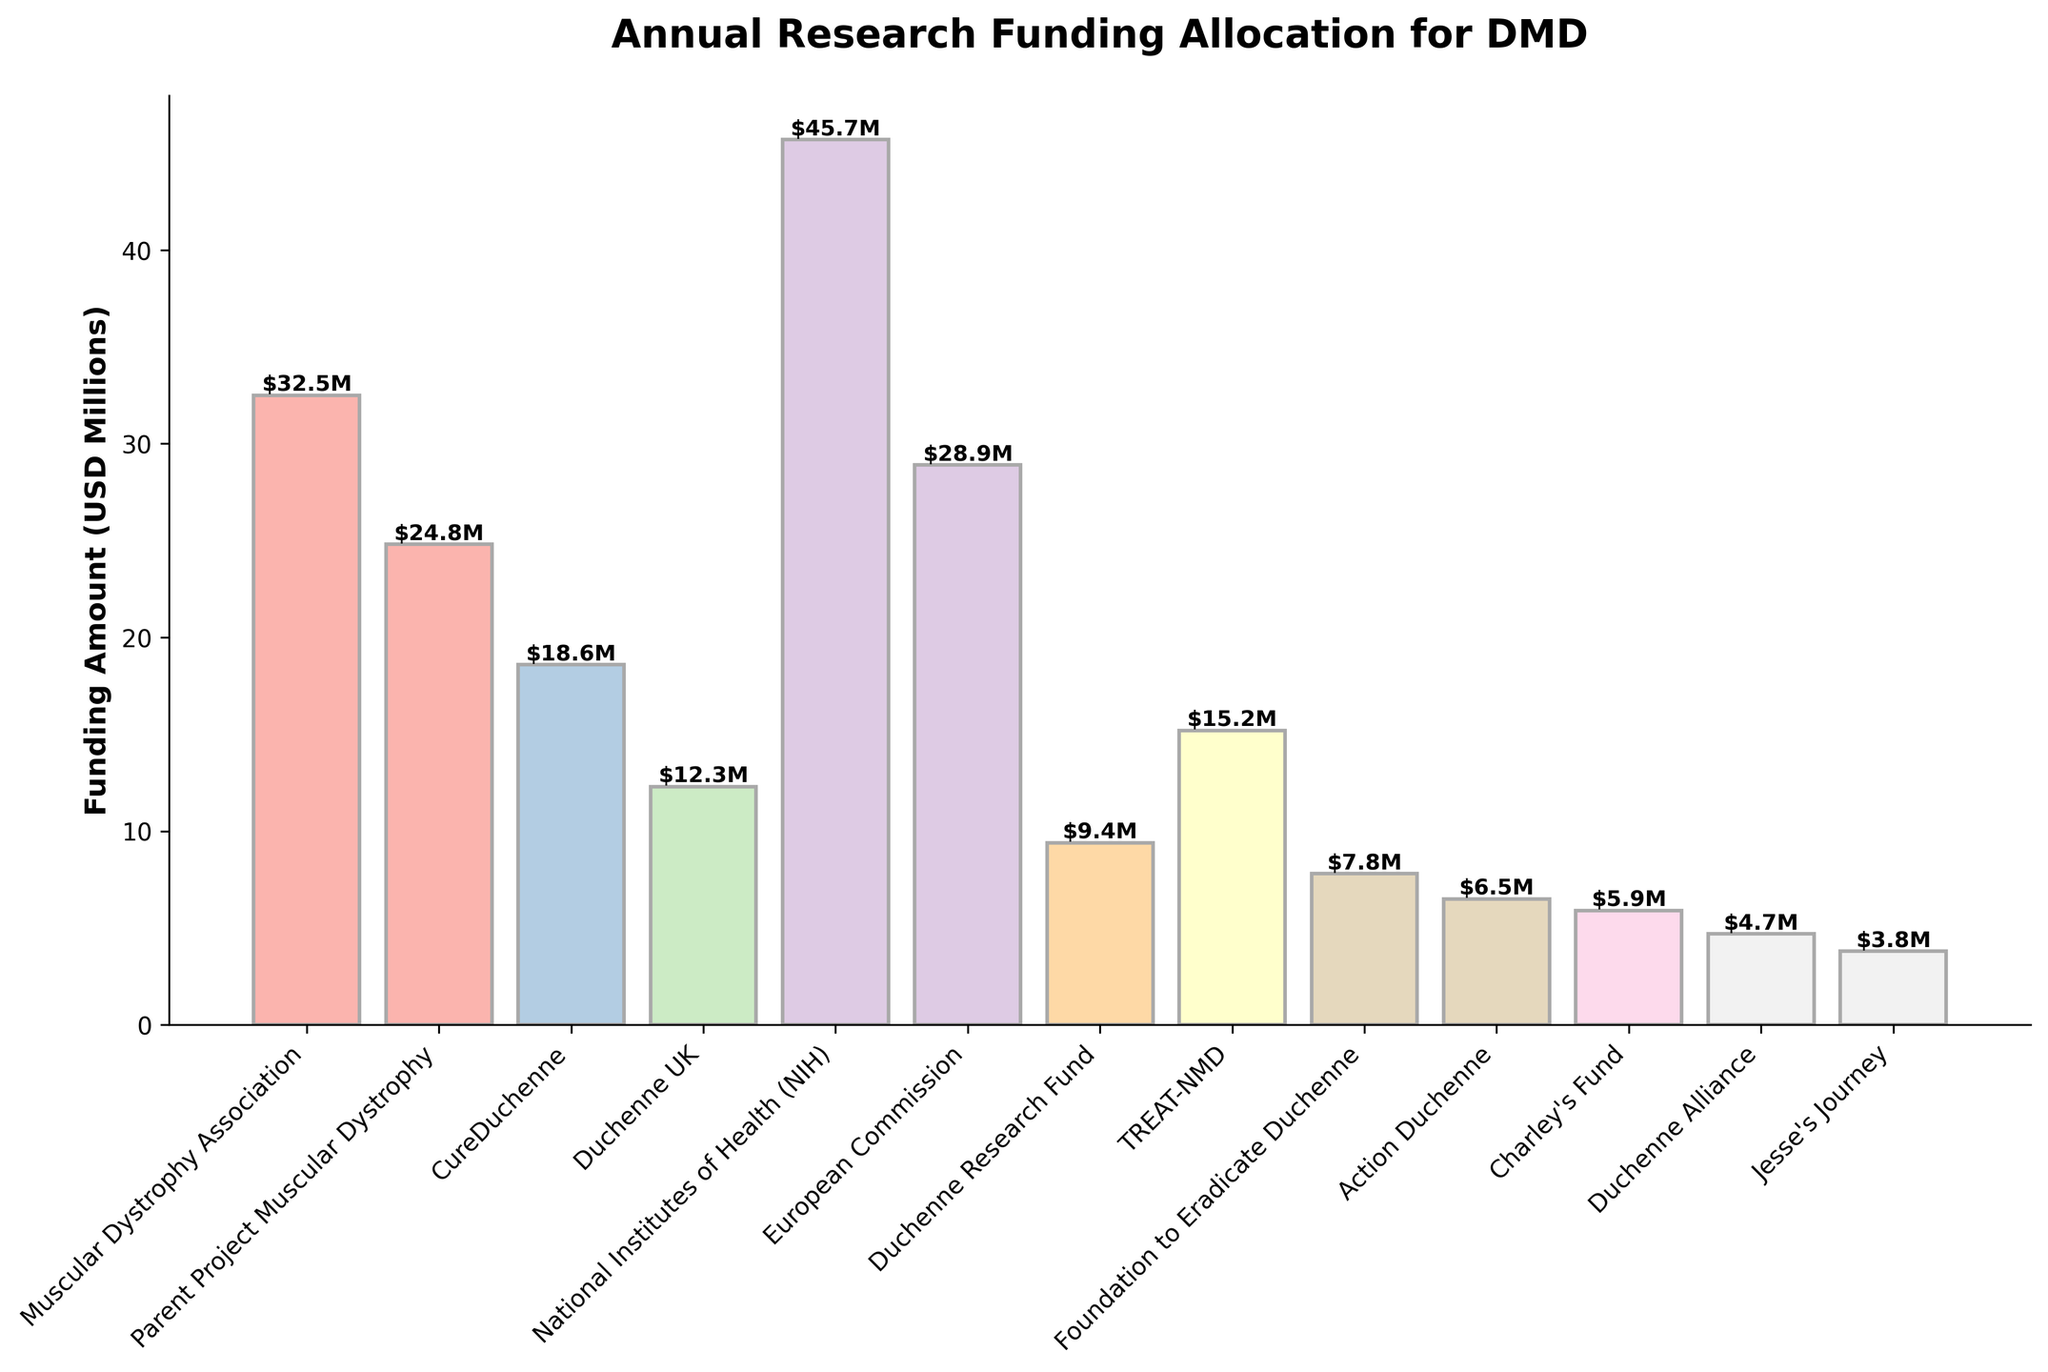Which organization has received the highest amount of funding? The tallest bar on the chart represents the organization with the highest amount of funding. In this case, the National Institutes of Health (NIH) has the tallest bar.
Answer: National Institutes of Health (NIH) How much more funding did the Muscular Dystrophy Association receive than the Duchenne Research Fund? To find the difference, subtract the funding amount of the Duchenne Research Fund from that of the Muscular Dystrophy Association. Muscular Dystrophy Association received 32.5M, and Duchenne Research Fund received 9.4M. So, 32.5 - 9.4 = 23.1M.
Answer: 23.1M What is the total funding allocated by Duchenne UK and Action Duchenne together? To find the combined funding, add the amounts allocated by both organizations. Duchenne UK received 12.3M and Action Duchenne received 6.5M. So, 12.3 + 6.5 = 18.8M.
Answer: 18.8M Which organization has the lowest funding, and what is the amount? The shortest bar on the chart represents the organization with the lowest amount of funding. The Duchenne Alliance has received the least funding, which is 4.7M.
Answer: Duchenne Alliance, 4.7M How much total funding is allocated by all the organizations combined? To find the total funding, sum all the individual amounts. 32.5 + 24.8 + 18.6 + 12.3 + 45.7 + 28.9 + 9.4 + 15.2 + 7.8 + 6.5 + 5.9 + 4.7 + 3.8 = 216.1M.
Answer: 216.1M What is the average funding amount across all organizations? To find the average, divide the total funding by the number of organizations. The total funding is 216.1M and there are 13 organizations. So, 216.1 / 13 ≈ 16.62M.
Answer: 16.62M Which organization has received more funding: CureDuchenne or TREAT-NMD? Compare the bar heights of CureDuchenne and TREAT-NMD. CureDuchenne received 18.6M, whereas TREAT-NMD received 15.2M. Since 18.6 is greater than 15.2, CureDuchenne has received more funding.
Answer: CureDuchenne Are there any organizations that received the same amount of funding? Look for bars with the same height on the chart. None of the bars have the same height, indicating that all funding amounts are unique.
Answer: No Approximately how much funding is allocated by organizations headquartered in the US (Muscular Dystrophy Association, Parent Project Muscular Dystrophy, CureDuchenne, National Institutes of Health, Duchenne Research Fund, Foundation to Eradicate Duchenne, Action Duchenne, Charley's Fund, Jesse's Journey)? Add up the funding amounts for these organizations: 32.5 + 24.8 + 18.6 + 45.7 + 9.4 + 7.8 + 6.5 + 5.9 + 3.8 ≈ 155M.
Answer: 155M 